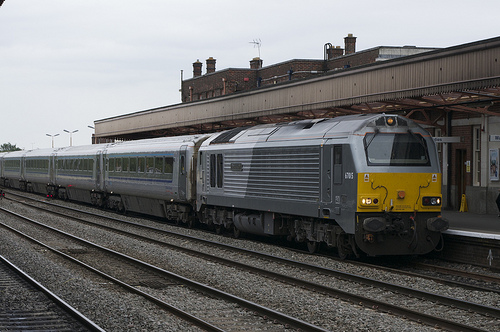Please provide the bounding box coordinate of the region this sentence describes: Small window on a train. The small window on the train can be accurately encompassed within the coordinates [0.41, 0.46, 0.46, 0.56]. This window is situated on the side of the train, a bit above midway in height. 